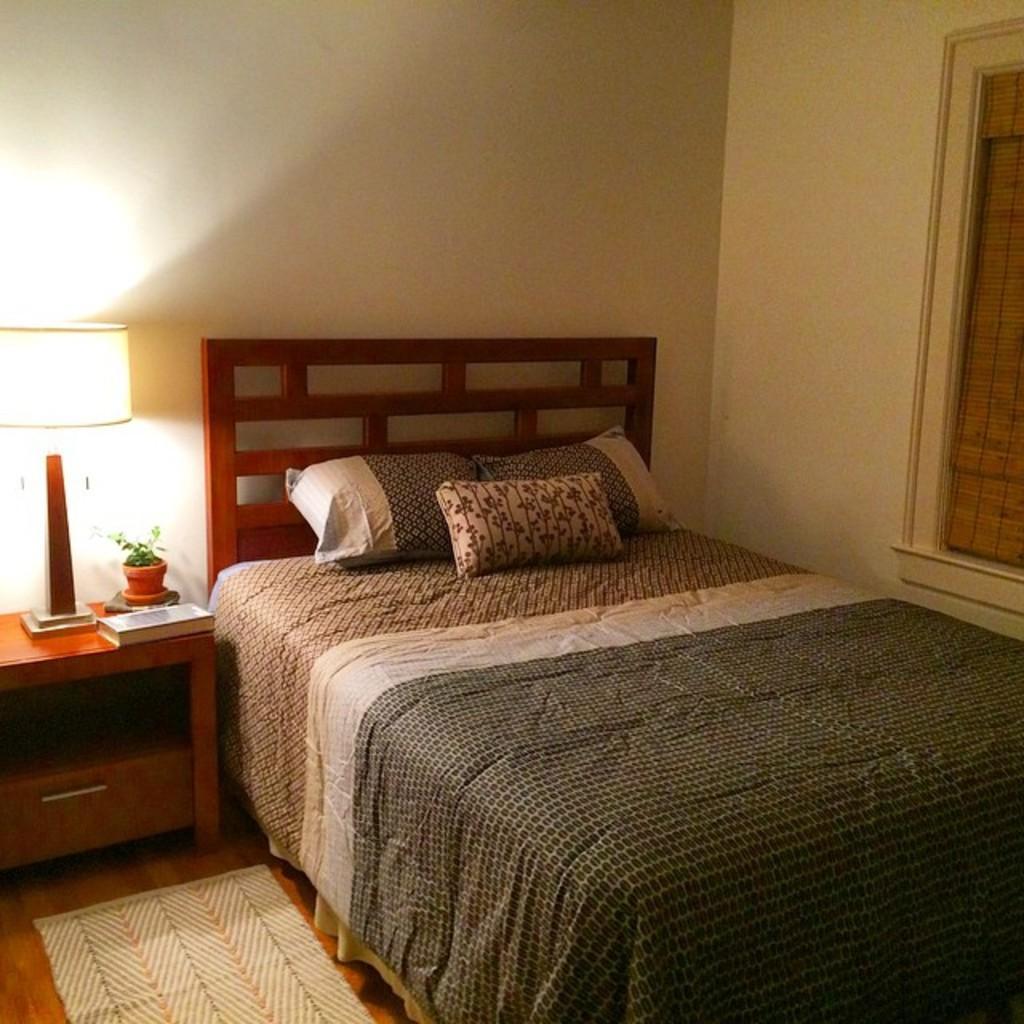Can you describe this image briefly? There are three pillows on a wooden bed as we can see in the middle of this image. There is a lamp and a book kept on a table on the left side of this image. There is a wall in the background , and there is a window on the right side of this image. There is a carpet on the floor at the bottom left corner of this image. 